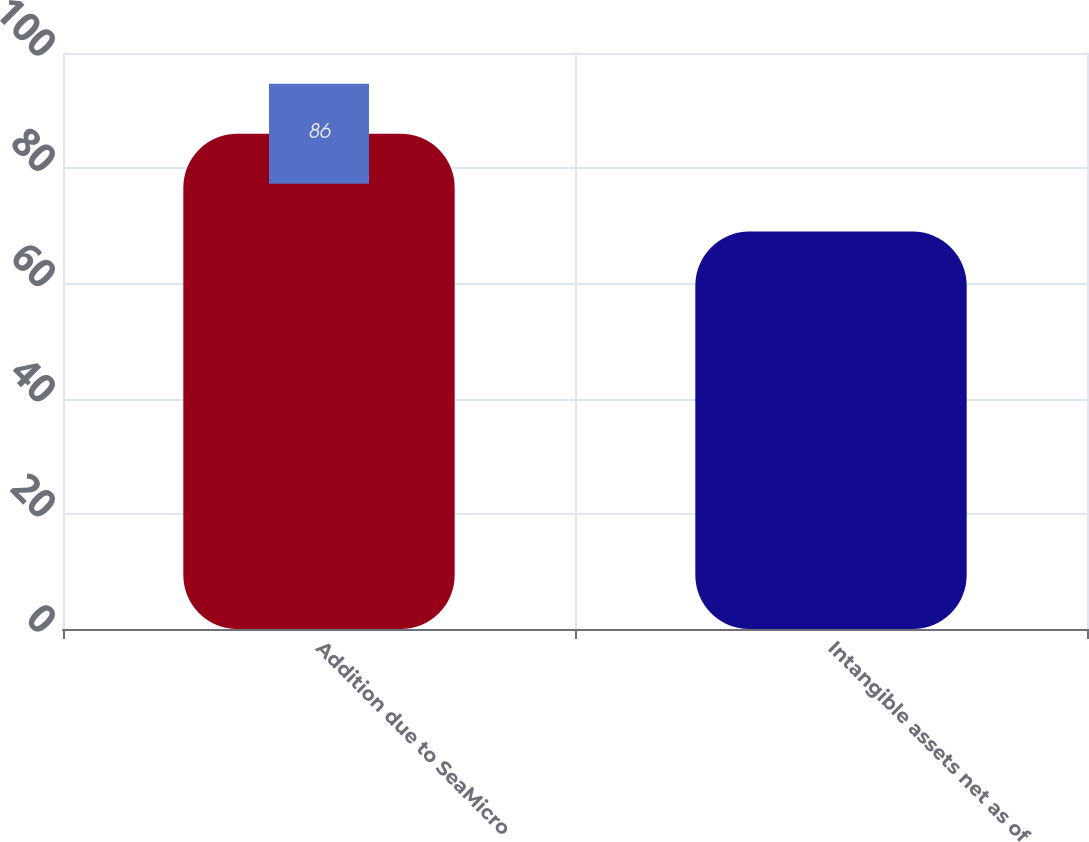Convert chart to OTSL. <chart><loc_0><loc_0><loc_500><loc_500><bar_chart><fcel>Addition due to SeaMicro<fcel>Intangible assets net as of<nl><fcel>86<fcel>69<nl></chart> 